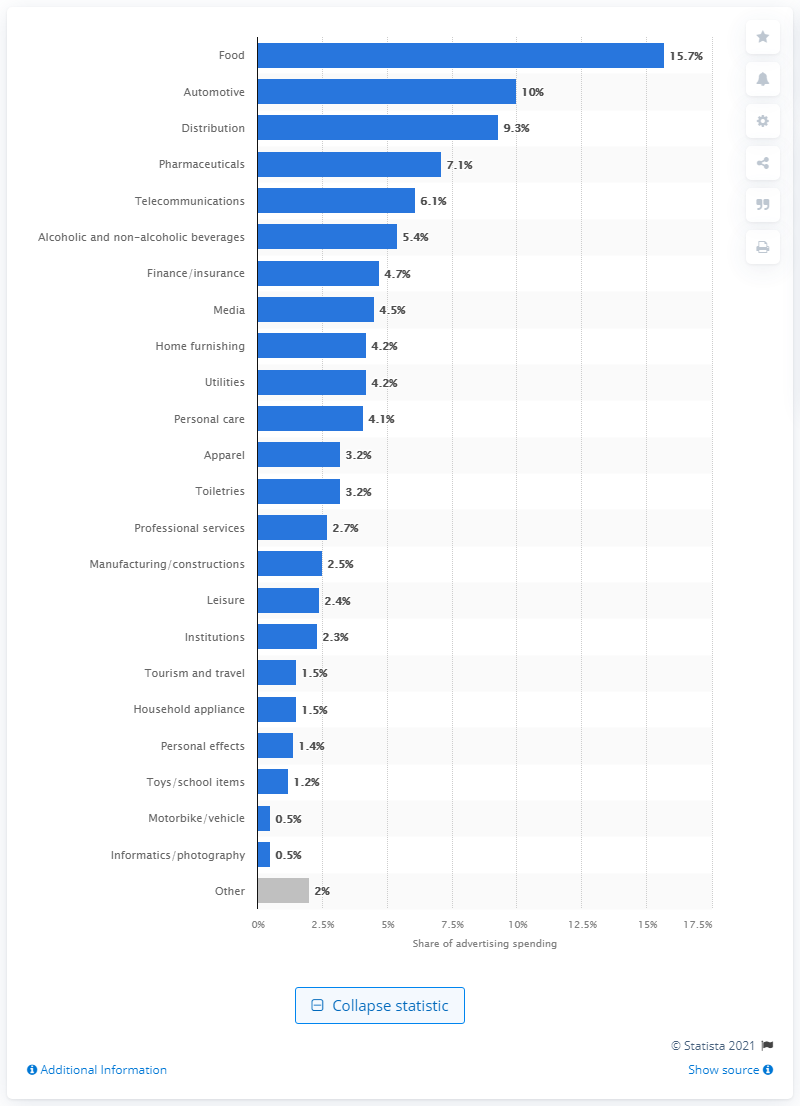Mention a couple of crucial points in this snapshot. In 2020, the automotive industry accounted for approximately 10% of Italy's total ad spend. 